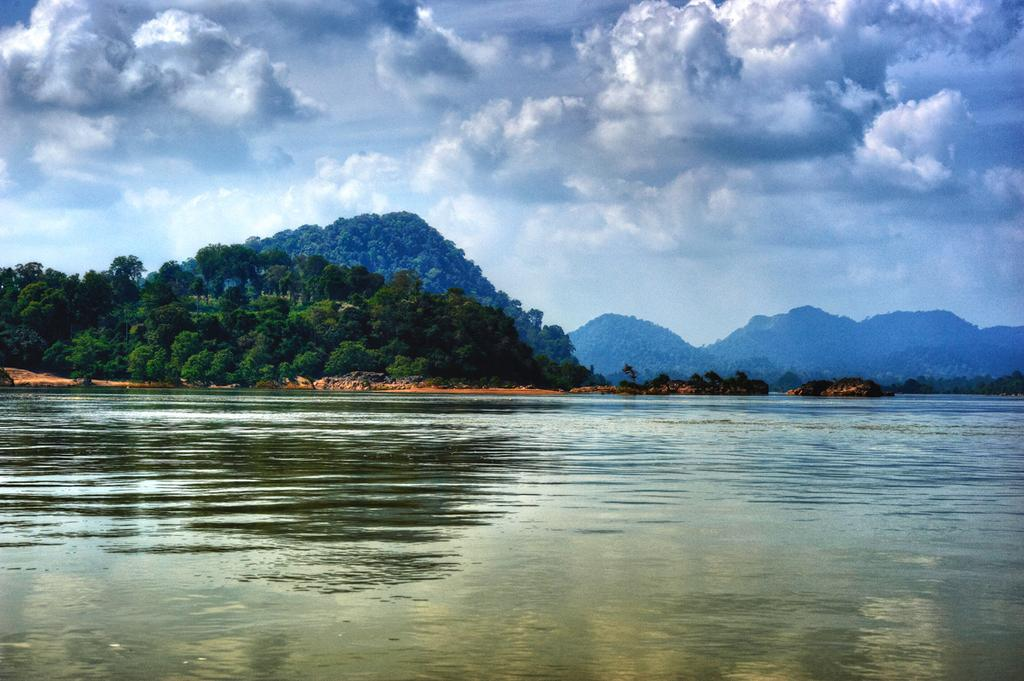What is the primary element visible in the image? There is water in the image. What type of natural features can be seen in the image? There are trees and mountains in the image. What is visible in the background of the image? The sky is visible in the image. What can be observed in the sky? Clouds are present in the sky. How many light bulbs are hanging from the trees in the image? There are no light bulbs present in the image; it features water, trees, mountains, and clouds. 